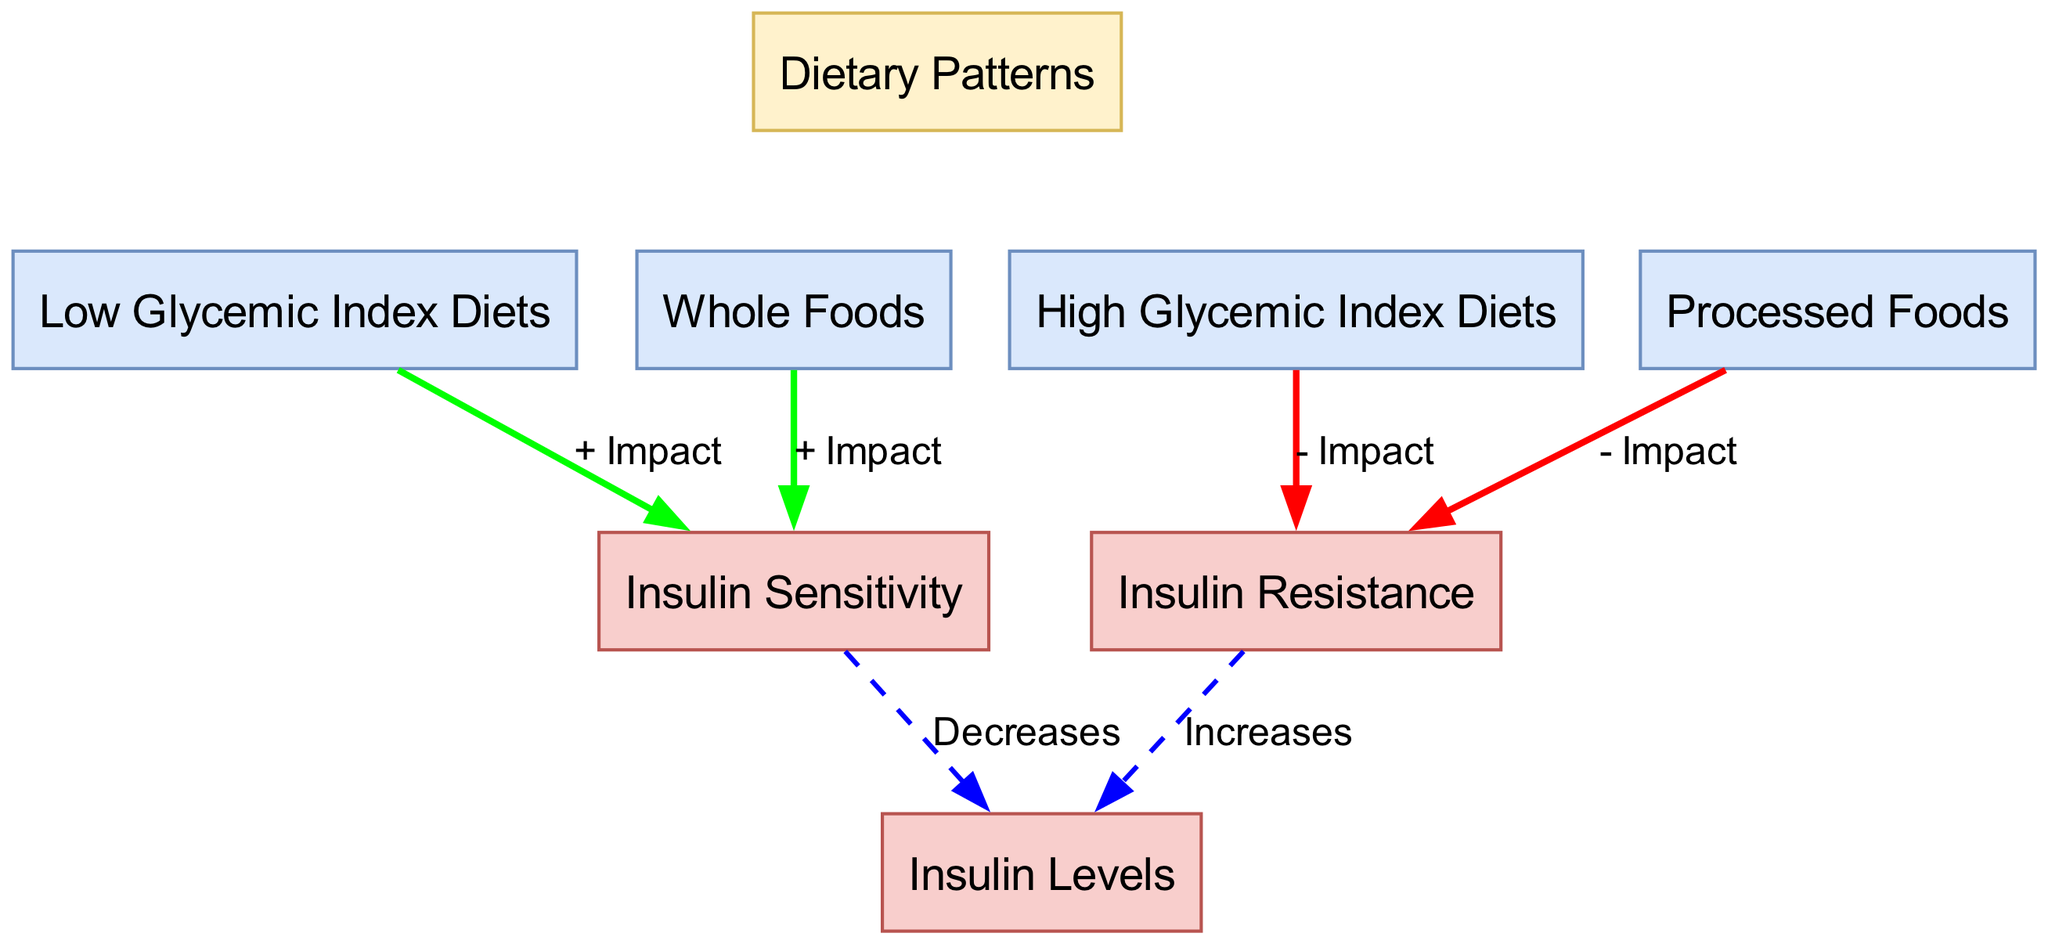What are the two types of dietary patterns mentioned? The diagram lists "Low Glycemic Index Diets" and "High Glycemic Index Diets" under the "Dietary Patterns" node.
Answer: Low Glycemic Index Diets, High Glycemic Index Diets How many nodes are there in total? Counting the nodes listed in the data, there are eight nodes: four dietary patterns, three insulin-related nodes, and the main dietary patterns node.
Answer: 8 Which dietary pattern has a negative impact on insulin sensitivity? The "High Glycemic Index Diets" node has an edge labeled "- Impact" pointing to "Insulin Resistance," indicating that it negatively affects insulin sensitivity.
Answer: High Glycemic Index Diets What is the connection between "Whole Foods" and "Insulin Sensitivity"? "Whole Foods" has a positive impact on "Insulin Sensitivity," as indicated by the edge labeled "+ Impact" between these two nodes.
Answer: + Impact If insulin resistance increases, what happens to insulin levels? The arrow from "Insulin Resistance" to "Insulin Levels" shows that as insulin resistance increases, insulin levels also increase.
Answer: Increases Which dietary pattern is associated with a positive impact on insulin sensitivity? The diagram indicates that "Low Glycemic Index Diets" and "Whole Foods" both have edges labeled "+ Impact" pointing to "Insulin Sensitivity."
Answer: Low Glycemic Index Diets, Whole Foods What effect do processed foods have on insulin resistance? The "Processed Foods" node is connected to "Insulin Resistance" by a "- Impact" edge, showing that processed foods contribute negatively to insulin resistance.
Answer: - Impact What is the overall effect of insulin sensitivity on insulin levels? The diagram illustrates that "Insulin Sensitivity" positively affects insulin levels by decreasing them. This is represented by the edge labeled "Decreases."
Answer: Decreases What is the color of the node representing dietary patterns? The "Dietary Patterns" node is filled with a color representing the main concept, exhibiting a light yellow shade as evidenced by the fill color code.
Answer: Light yellow 